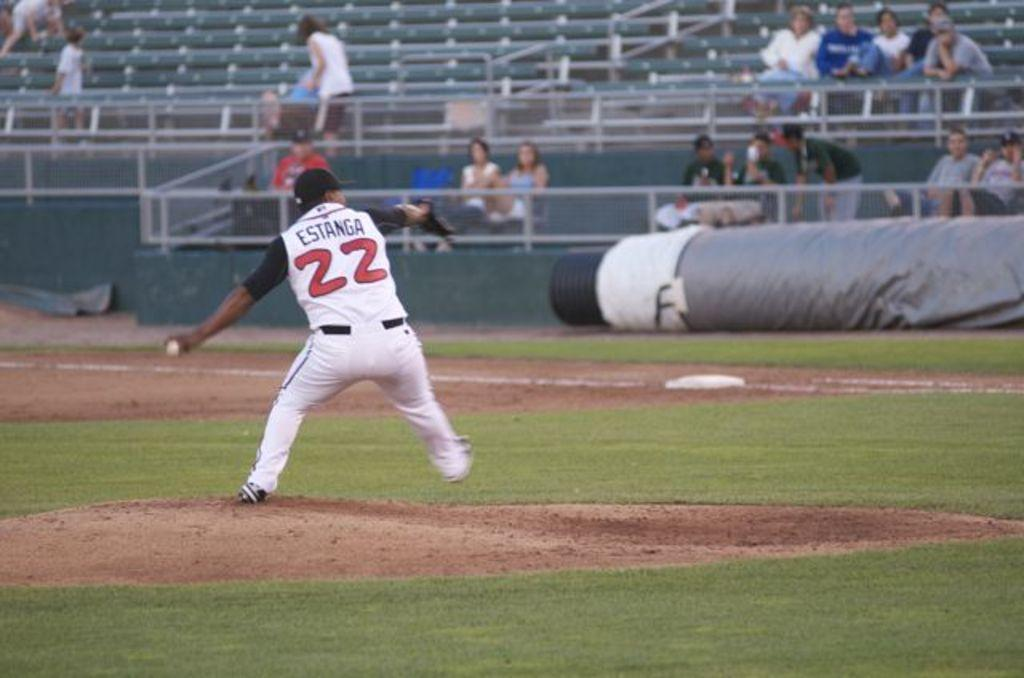<image>
Relay a brief, clear account of the picture shown. A baseball player, with "Estanga 22" on his uniform, is throwing a pitch. 